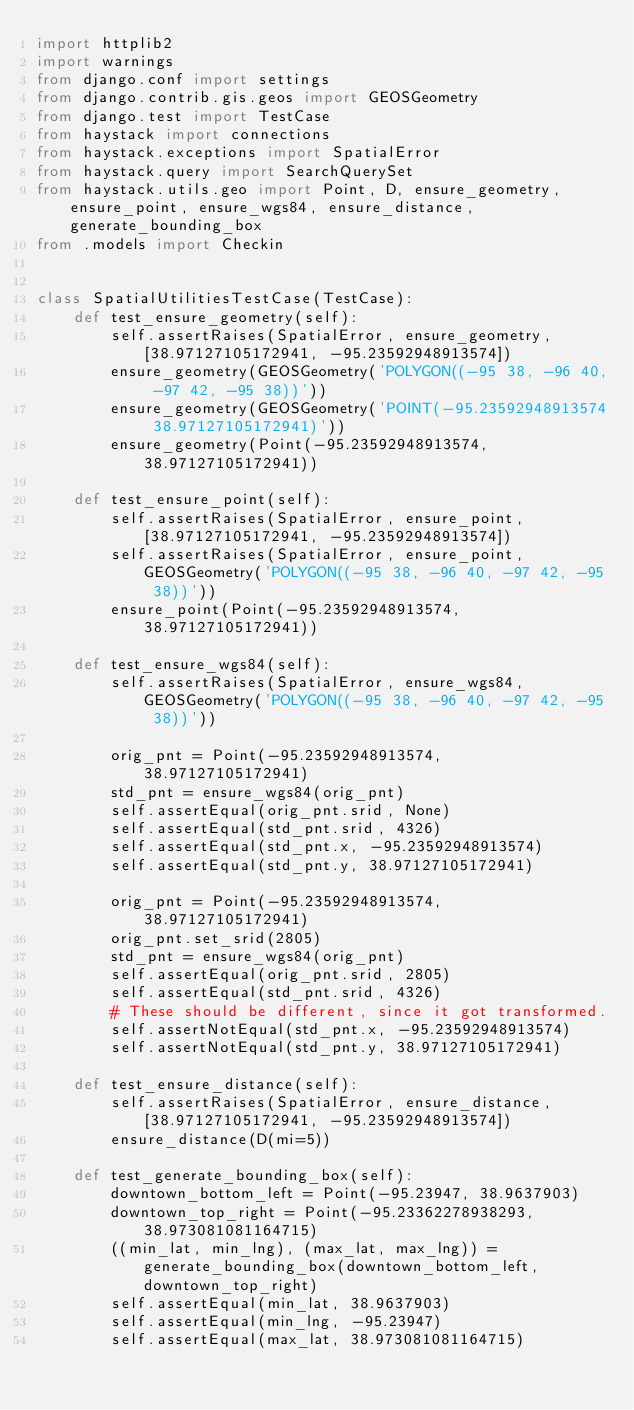Convert code to text. <code><loc_0><loc_0><loc_500><loc_500><_Python_>import httplib2
import warnings
from django.conf import settings
from django.contrib.gis.geos import GEOSGeometry
from django.test import TestCase
from haystack import connections
from haystack.exceptions import SpatialError
from haystack.query import SearchQuerySet
from haystack.utils.geo import Point, D, ensure_geometry, ensure_point, ensure_wgs84, ensure_distance, generate_bounding_box
from .models import Checkin


class SpatialUtilitiesTestCase(TestCase):
    def test_ensure_geometry(self):
        self.assertRaises(SpatialError, ensure_geometry, [38.97127105172941, -95.23592948913574])
        ensure_geometry(GEOSGeometry('POLYGON((-95 38, -96 40, -97 42, -95 38))'))
        ensure_geometry(GEOSGeometry('POINT(-95.23592948913574 38.97127105172941)'))
        ensure_geometry(Point(-95.23592948913574, 38.97127105172941))

    def test_ensure_point(self):
        self.assertRaises(SpatialError, ensure_point, [38.97127105172941, -95.23592948913574])
        self.assertRaises(SpatialError, ensure_point, GEOSGeometry('POLYGON((-95 38, -96 40, -97 42, -95 38))'))
        ensure_point(Point(-95.23592948913574, 38.97127105172941))

    def test_ensure_wgs84(self):
        self.assertRaises(SpatialError, ensure_wgs84, GEOSGeometry('POLYGON((-95 38, -96 40, -97 42, -95 38))'))

        orig_pnt = Point(-95.23592948913574, 38.97127105172941)
        std_pnt = ensure_wgs84(orig_pnt)
        self.assertEqual(orig_pnt.srid, None)
        self.assertEqual(std_pnt.srid, 4326)
        self.assertEqual(std_pnt.x, -95.23592948913574)
        self.assertEqual(std_pnt.y, 38.97127105172941)

        orig_pnt = Point(-95.23592948913574, 38.97127105172941)
        orig_pnt.set_srid(2805)
        std_pnt = ensure_wgs84(orig_pnt)
        self.assertEqual(orig_pnt.srid, 2805)
        self.assertEqual(std_pnt.srid, 4326)
        # These should be different, since it got transformed.
        self.assertNotEqual(std_pnt.x, -95.23592948913574)
        self.assertNotEqual(std_pnt.y, 38.97127105172941)

    def test_ensure_distance(self):
        self.assertRaises(SpatialError, ensure_distance, [38.97127105172941, -95.23592948913574])
        ensure_distance(D(mi=5))

    def test_generate_bounding_box(self):
        downtown_bottom_left = Point(-95.23947, 38.9637903)
        downtown_top_right = Point(-95.23362278938293, 38.973081081164715)
        ((min_lat, min_lng), (max_lat, max_lng)) = generate_bounding_box(downtown_bottom_left, downtown_top_right)
        self.assertEqual(min_lat, 38.9637903)
        self.assertEqual(min_lng, -95.23947)
        self.assertEqual(max_lat, 38.973081081164715)</code> 